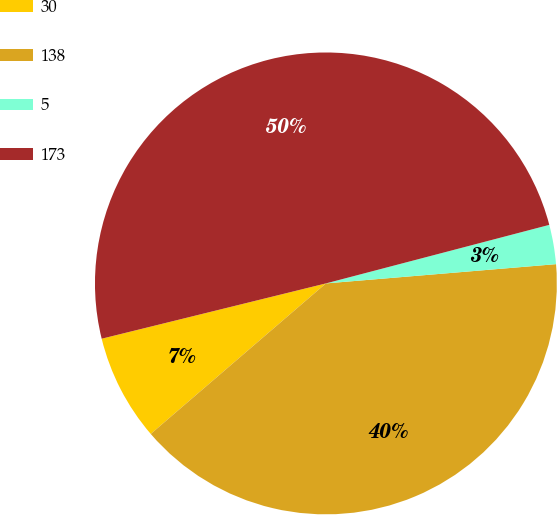Convert chart to OTSL. <chart><loc_0><loc_0><loc_500><loc_500><pie_chart><fcel>30<fcel>138<fcel>5<fcel>173<nl><fcel>7.45%<fcel>40.03%<fcel>2.75%<fcel>49.77%<nl></chart> 